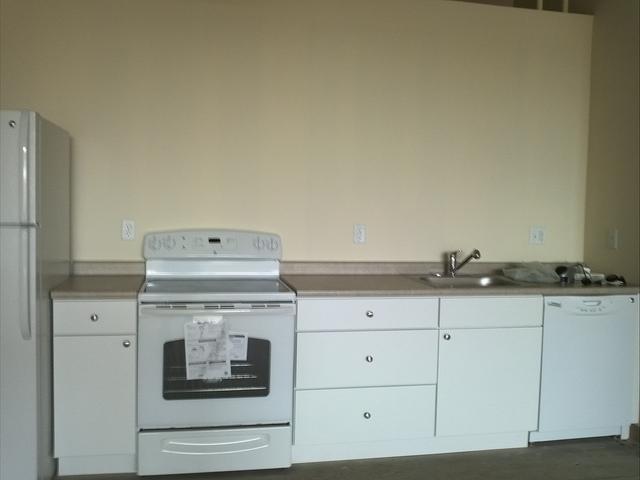What material are the appliances made of?
Quick response, please. Metal. What is the main color in the room?
Answer briefly. White. Is the room clean?
Short answer required. Yes. What color is the wall?
Answer briefly. Tan. Is the faucet turned on?
Short answer required. No. What color is the stove?
Concise answer only. White. What appliance besides a microwave is visible?
Short answer required. Stove. Do the appliances appear to be new?
Answer briefly. Yes. What color is the sink?
Concise answer only. Silver. Does someone live here?
Answer briefly. No. 